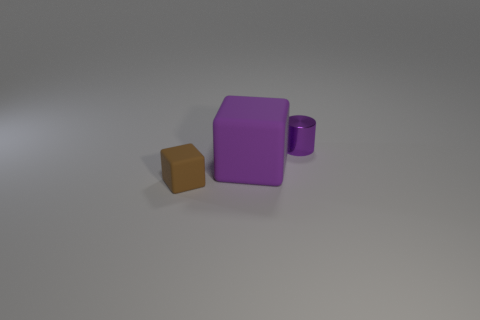Add 1 red matte spheres. How many objects exist? 4 Subtract all cylinders. How many objects are left? 2 Subtract 1 purple cylinders. How many objects are left? 2 Subtract all large metallic cylinders. Subtract all purple matte blocks. How many objects are left? 2 Add 3 rubber things. How many rubber things are left? 5 Add 2 tiny purple metallic objects. How many tiny purple metallic objects exist? 3 